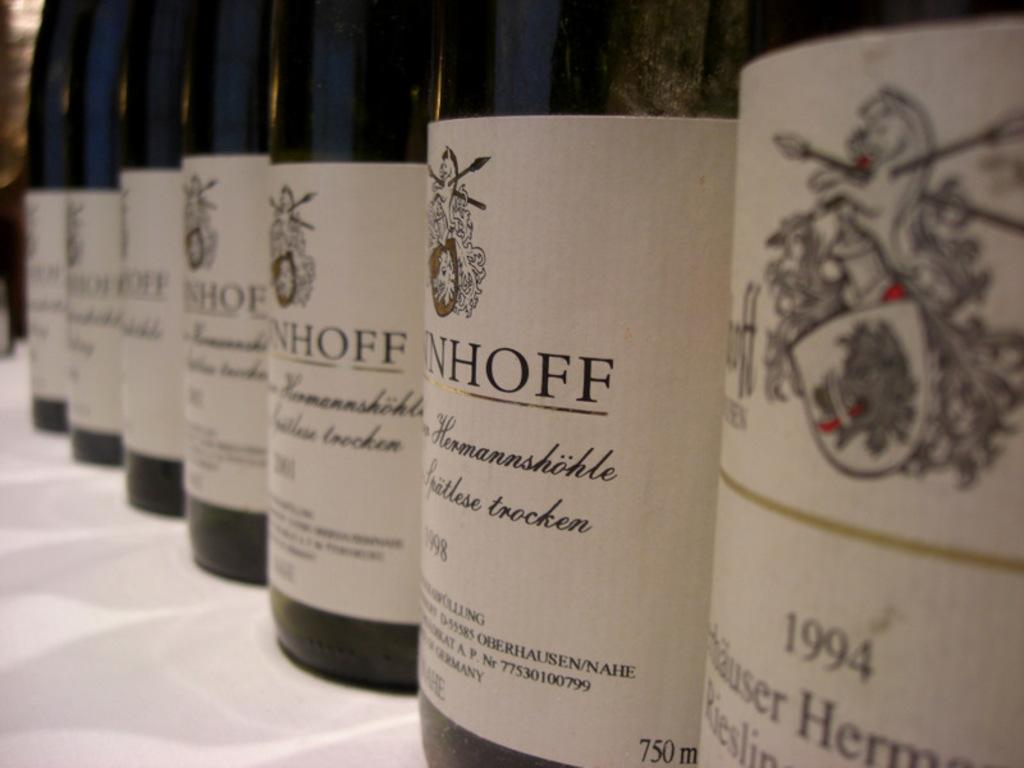<image>
Create a compact narrative representing the image presented. Several Riesling wine bottles lined up on tablecloth all of different years, such as 1994 and 1998. 